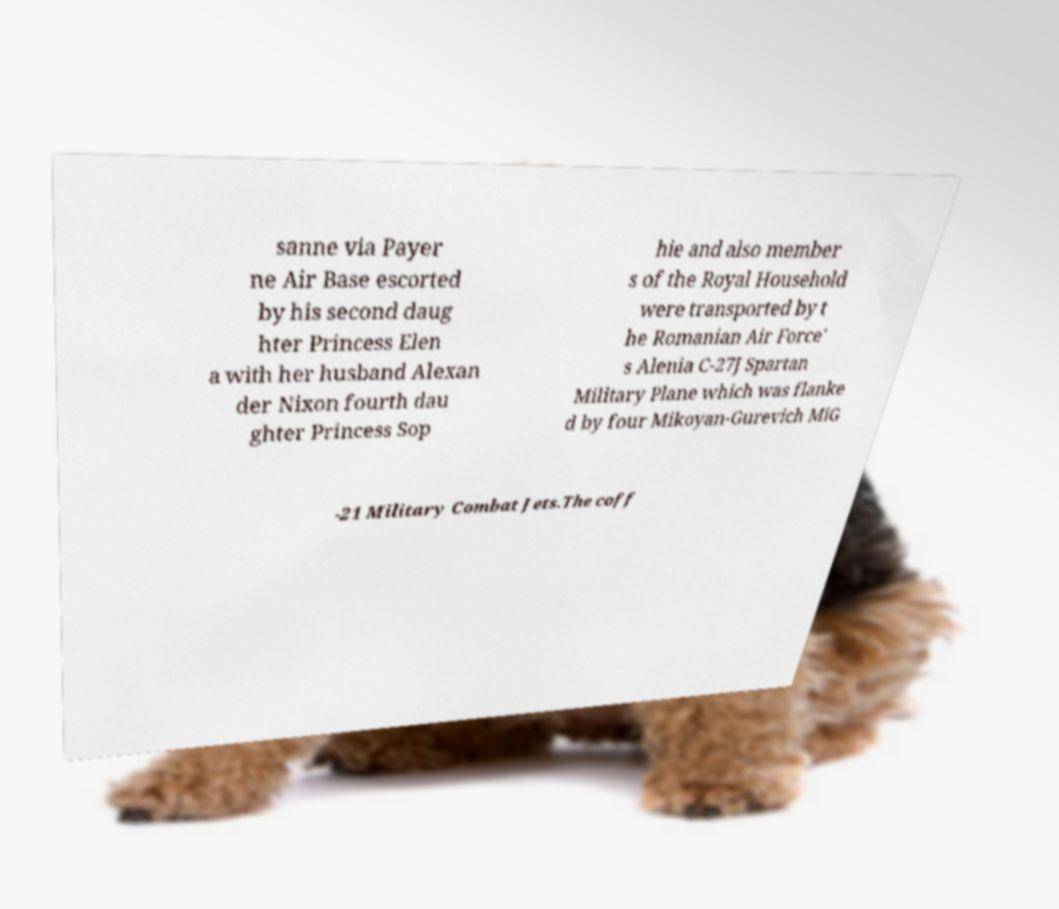Please read and relay the text visible in this image. What does it say? sanne via Payer ne Air Base escorted by his second daug hter Princess Elen a with her husband Alexan der Nixon fourth dau ghter Princess Sop hie and also member s of the Royal Household were transported by t he Romanian Air Force' s Alenia C-27J Spartan Military Plane which was flanke d by four Mikoyan-Gurevich MiG -21 Military Combat Jets.The coff 